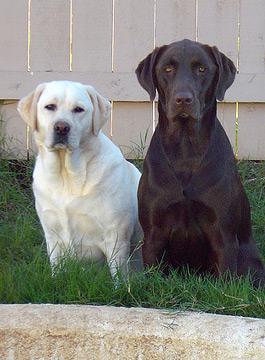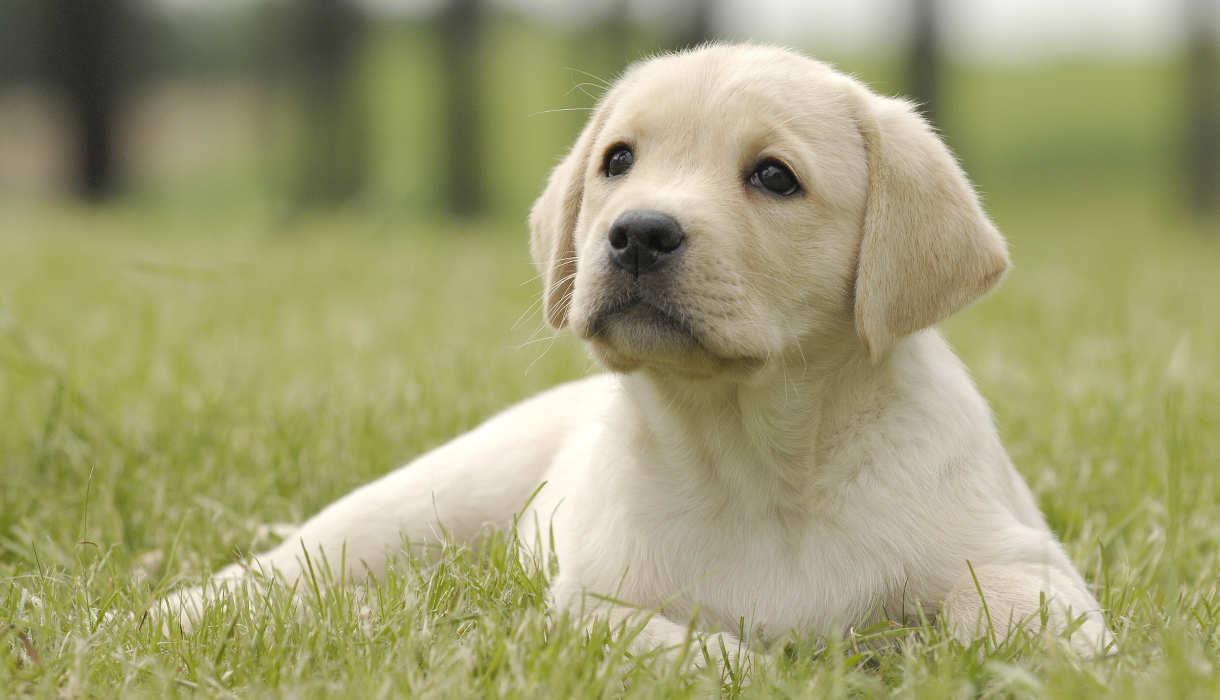The first image is the image on the left, the second image is the image on the right. Evaluate the accuracy of this statement regarding the images: "Four dogs exactly can be seen on the pair of images.". Is it true? Answer yes or no. No. The first image is the image on the left, the second image is the image on the right. Analyze the images presented: Is the assertion "An image contains exactly two dogs sitting upright, with the darker dog on the right." valid? Answer yes or no. Yes. 